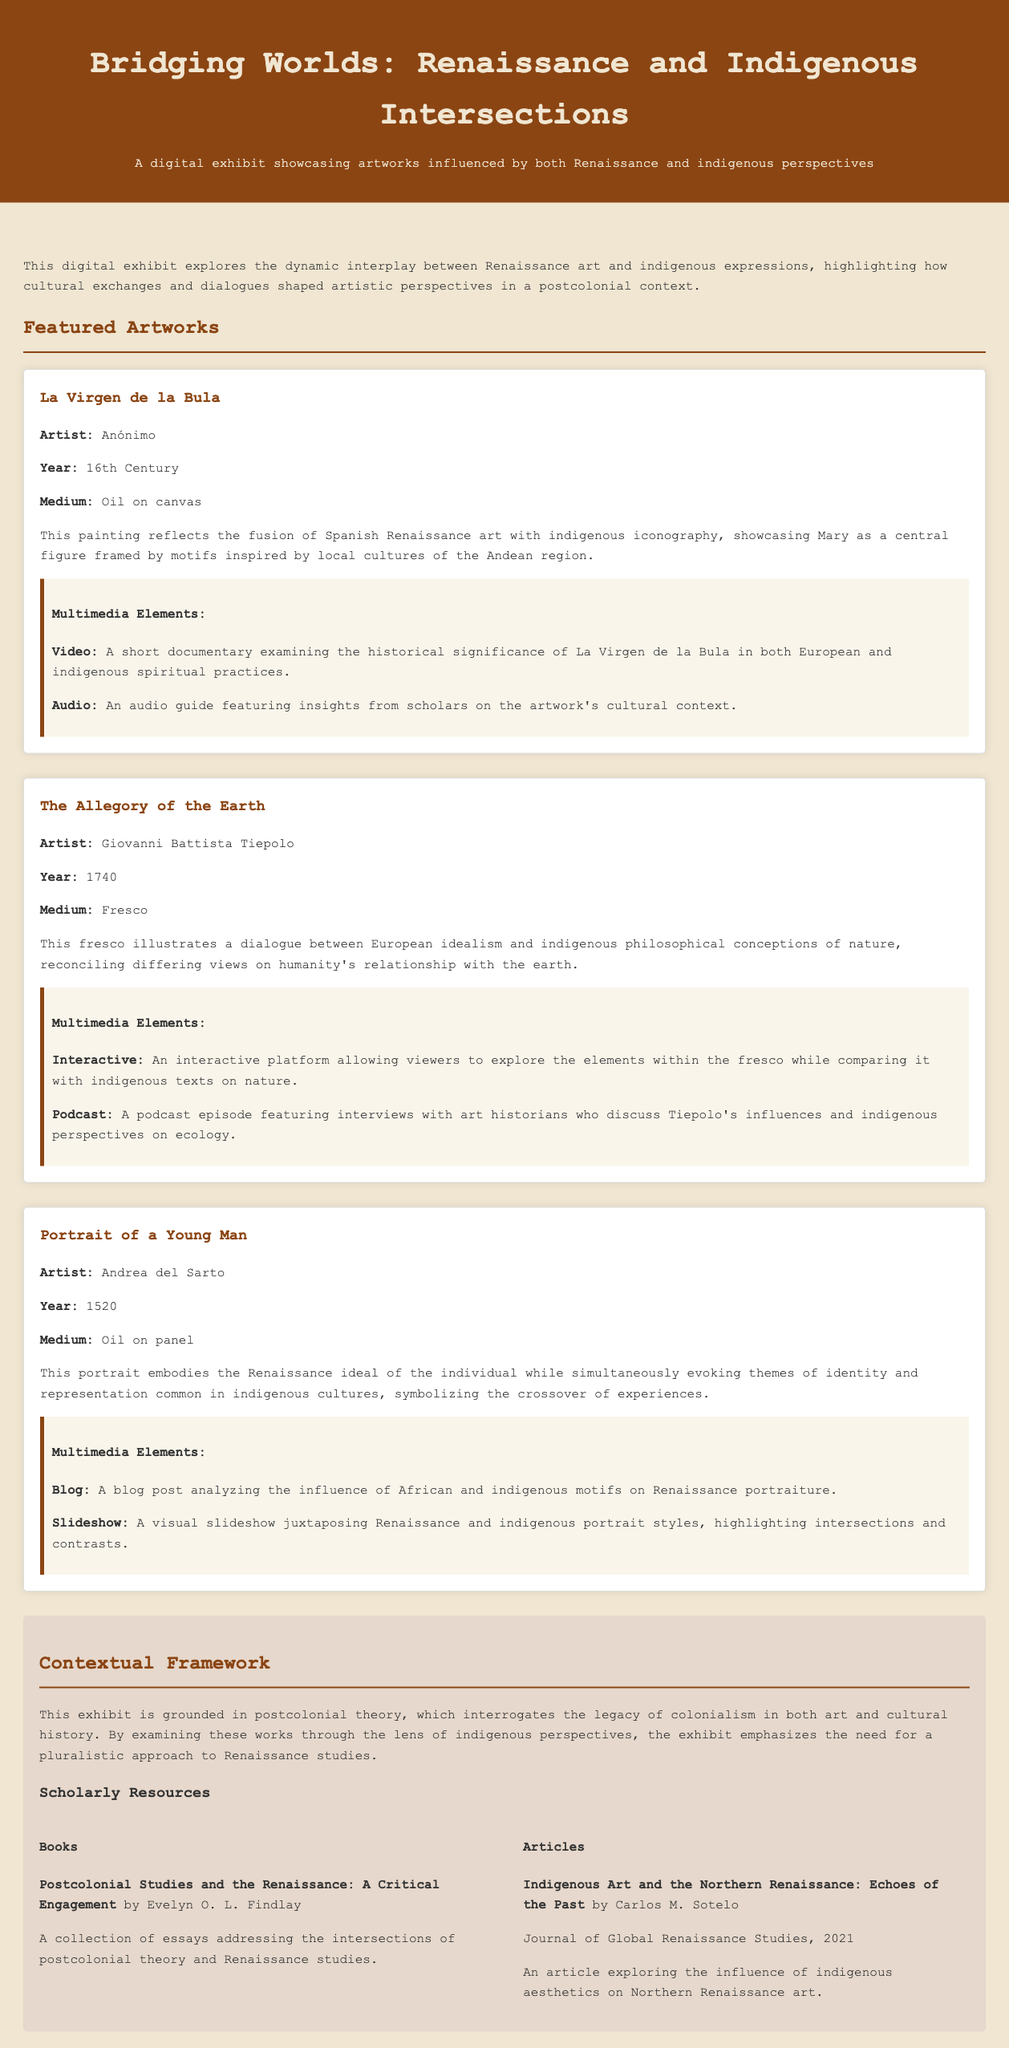What is the title of the exhibit? The title of the exhibit is presented prominently at the top of the document.
Answer: Bridging Worlds: Renaissance and Indigenous Intersections Who is the artist of "La Virgen de la Bula"? The artist of "La Virgen de la Bula" is mentioned in the description section of the artwork.
Answer: Anónimo What year was "The Allegory of the Earth" created? The year of creation for "The Allegory of the Earth" is stated under the artwork details.
Answer: 1740 What medium is used for "Portrait of a Young Man"? The medium is specified in the details of "Portrait of a Young Man".
Answer: Oil on panel How many multimedia elements are listed for "La Virgen de la Bula"? The document lists the multimedia elements under each artwork.
Answer: Two What theme does the exhibit emphasize? The theme is stated in the contextual framework of the exhibit, reflecting its main focus.
Answer: Pluralistic approach Who is the author of the book mentioned in the scholarly resources? The author is provided along with the book title in the resources section.
Answer: Evelyn O. L. Findlay What is discussed in the podcast episode related to "The Allegory of the Earth"? The content of the podcast is briefly described in the multimedia section of the artwork.
Answer: Interviews with art historians Which indigenous art concept is addressed in Carlos M. Sotelo's article? The content of the article is summarized within the article entry in the resources section.
Answer: Influence of indigenous aesthetics on Northern Renaissance art 